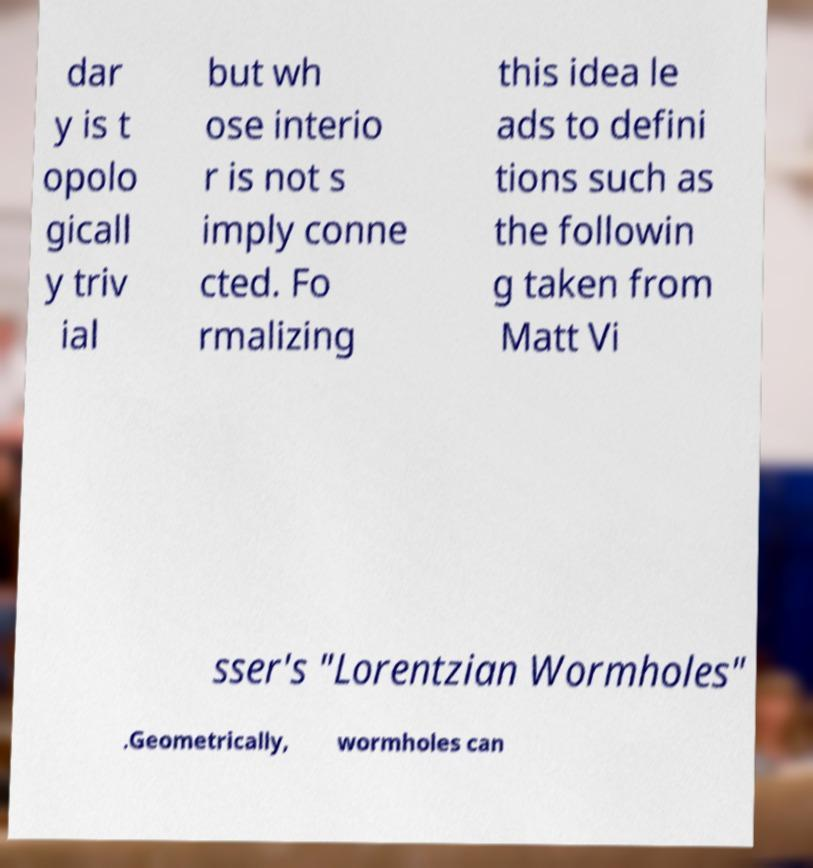Can you accurately transcribe the text from the provided image for me? dar y is t opolo gicall y triv ial but wh ose interio r is not s imply conne cted. Fo rmalizing this idea le ads to defini tions such as the followin g taken from Matt Vi sser's "Lorentzian Wormholes" .Geometrically, wormholes can 